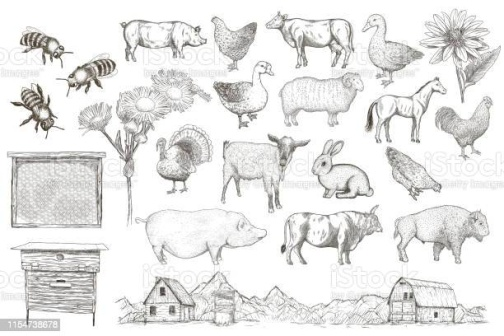What might a typical day be like for the farmer who owns this farm? A typical day for the farmer begins in the early hours before the first light of dawn. With a trusty lantern in hand, the farmer makes the rounds, greeting each animal with familiar affection. The day starts with feeding the animals – tossing grains to the chickens, filling troughs with fresh hay for the cows and sheep, and ensuring the pigs have their fill.

Next, the farmer checks on the beehives, carefully inspecting for signs of healthy activity and collecting honey when the time is ripe. After this, attention turns to the fields where crops are carefully tended. Whether it's sowing seeds, watering, or weeding, the farmer dedicates time and effort to ensure a bountiful harvest.

Throughout the day, the farmer might mend fences, repair the barn, and check on the well-being of each animal, providing any necessary medical care. Lunchtime is usually a brief respite, often enjoyed under the shadow of the grand oak tree, surrounded by the gentle sounds of farm life. Afternoons are spent on various chores such as gathering eggs, milking cows, and ensuring the farm runs smoothly.

As the sun sets, the farmer rounds up the animals, guiding them safely back to their pens and coops. The end of the day involves a quiet moment, surveying the farm, feeling a deep sense of satisfaction and connection to the land and its inhabitants. The farmer heads home, resting early to rise with the dawn and begin another fulfilling day on the farm.  How might the introduction of a new animal species to the farm impact the existing balance? Introducing a new animal species to the farm can have various impacts, both positive and challenging. If the new species is a natural complement to the existing ecosystem, it can enhance the farm's biodiversity, bringing benefits such as improved pest control, pollination, and soil health.

However, it can also introduce new dynamics that need to be carefully managed. For instance, if the new animal has different dietary needs or behaviors, the farmer will need to adjust feeding routines and enclosures. It's crucial to ensure the new species can coexist peacefully with the current animals without causing stress or competition for resources.

Overall, with thoughtful planning and gradual integration, the introduction of a new animal can enrich farm life, fostering a more resilient and diverse farm ecosystem. 